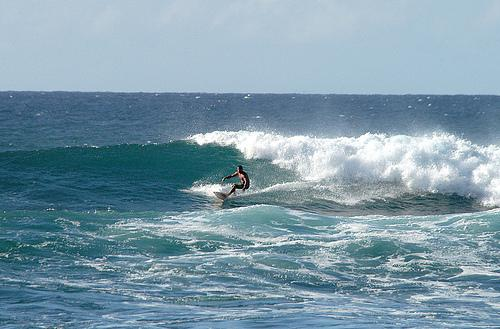Question: when was the picture taken?
Choices:
A. Daytime.
B. At night.
C. During the summer.
D. On vacation.
Answer with the letter. Answer: A Question: what color is the sky?
Choices:
A. Red.
B. Yellow.
C. Gray.
D. Blue.
Answer with the letter. Answer: D Question: where is the man?
Choices:
A. In the water.
B. On the beach.
C. Under umbrella.
D. On the surfboard.
Answer with the letter. Answer: D Question: what color is the surfboard?
Choices:
A. White.
B. Purple.
C. Red.
D. Black.
Answer with the letter. Answer: D Question: who is on the surfboard?
Choices:
A. A woman.
B. A dog.
C. The man.
D. A child.
Answer with the letter. Answer: C Question: how many men are there?
Choices:
A. Two.
B. Three.
C. Four.
D. One.
Answer with the letter. Answer: D 